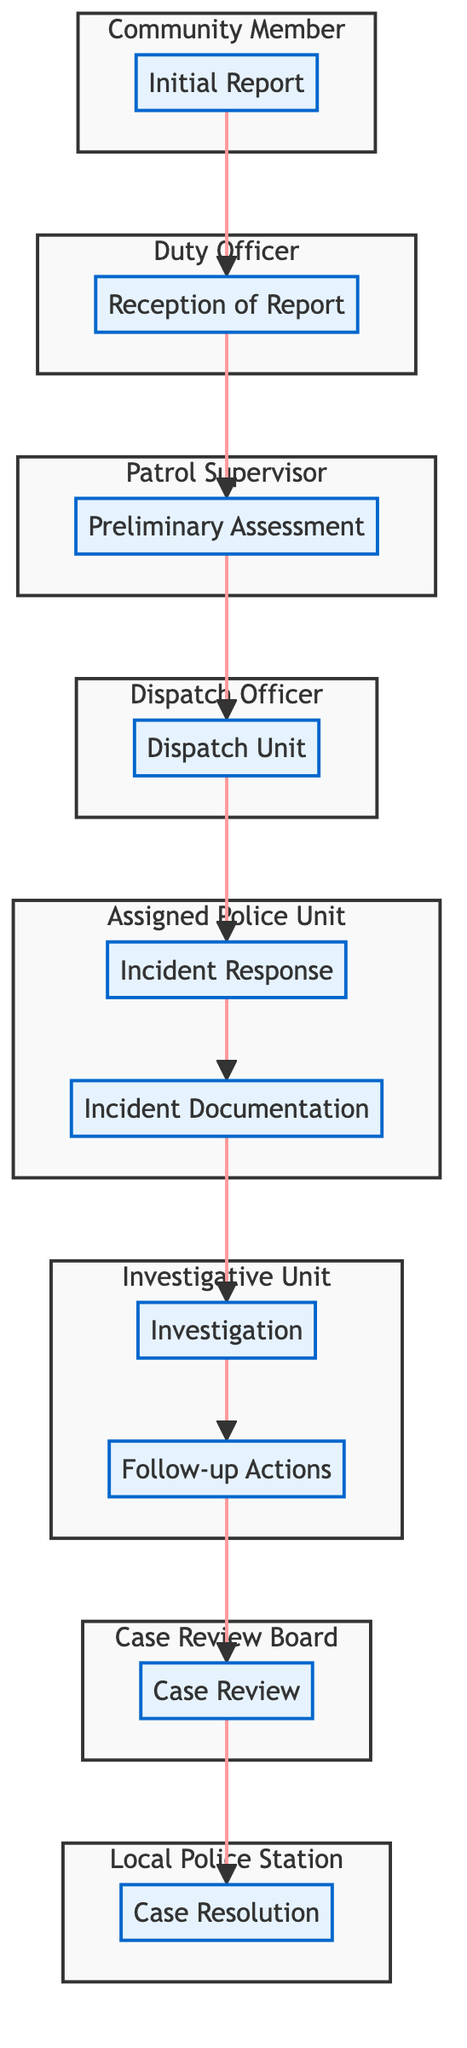What is the first step in the incident reporting procedure? The first step is labeled as "Initial Report," which indicates that a community member contacts the police station to report an incident.
Answer: Initial Report How many nodes are there in the diagram? By counting each step in the flow chart from "Initial Report" to "Case Resolution," we find 10 distinct elements.
Answer: 10 Who is responsible for the "Follow-up Actions"? The "Follow-up Actions" step is managed by the "Investigative Unit," as indicated in the diagram, which shows the responsibility linked with that stage of the process.
Answer: Investigative Unit What comes after the "Incident Documentation"? Following "Incident Documentation," the next step is "Investigation," showing the progression of actions taken after documenting the incident details.
Answer: Investigation Which element is responsible for receiving the initial report? The "Reception of Report" is the step responsible for logging the incident, and it falls under the duty of the "Duty Officer," as shown in the diagram.
Answer: Duty Officer What steps are under the responsibility of the "Assigned Police Unit"? The "Assigned Police Unit" is responsible for both "Incident Response" and "Incident Documentation," which are two consecutive steps in the procedure.
Answer: Incident Response, Incident Documentation Which element initiates the case resolution process? The case resolution process begins with the "Case Review," which ensures that all procedures have been correctly followed before finalizing the case.
Answer: Case Review Identify the final stage of the incident reporting procedure. The final stage is labeled "Case Resolution," where the incident report is concluded with any necessary resolutions.
Answer: Case Resolution What action follows the "Preliminary Assessment"? After conducting a "Preliminary Assessment," the police proceed to "Dispatch Unit," ensuring prompt response to the reported incident.
Answer: Dispatch Unit Which roles are involved in the procedure prior to the "Investigation"? Prior to the "Investigation," the roles involved include the "Assigned Police Unit" for both "Incident Response" and "Incident Documentation," highlighting the collaboration before investigation begins.
Answer: Assigned Police Unit 